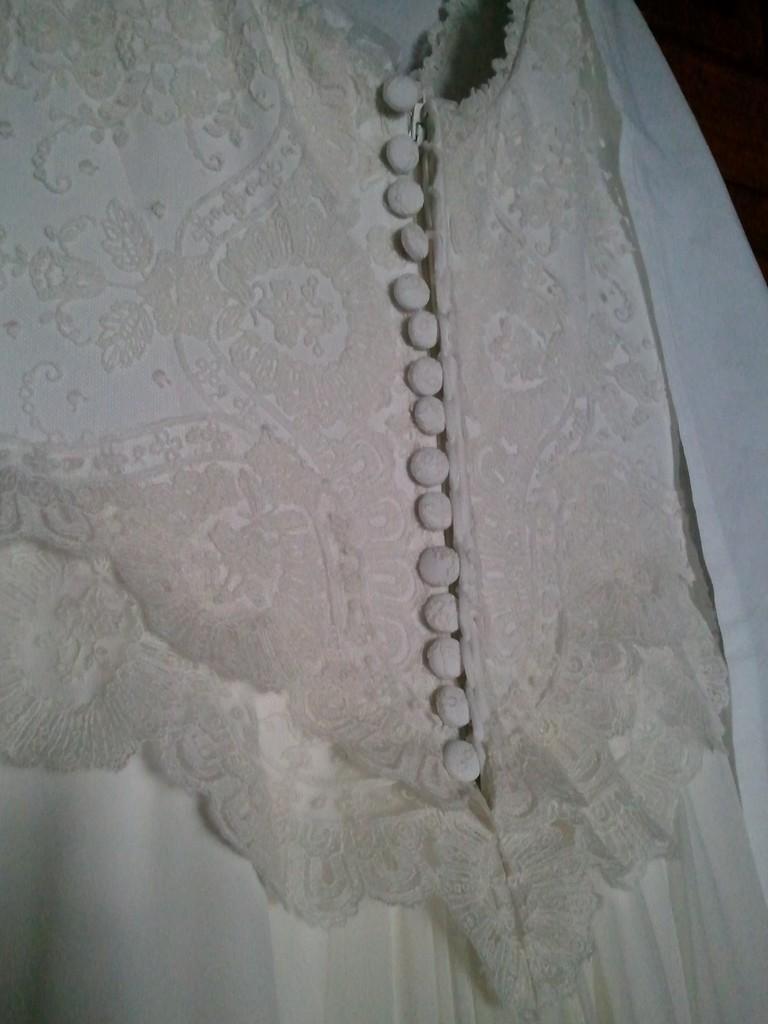Please provide a concise description of this image. Here we can see a dress which is in white color. 